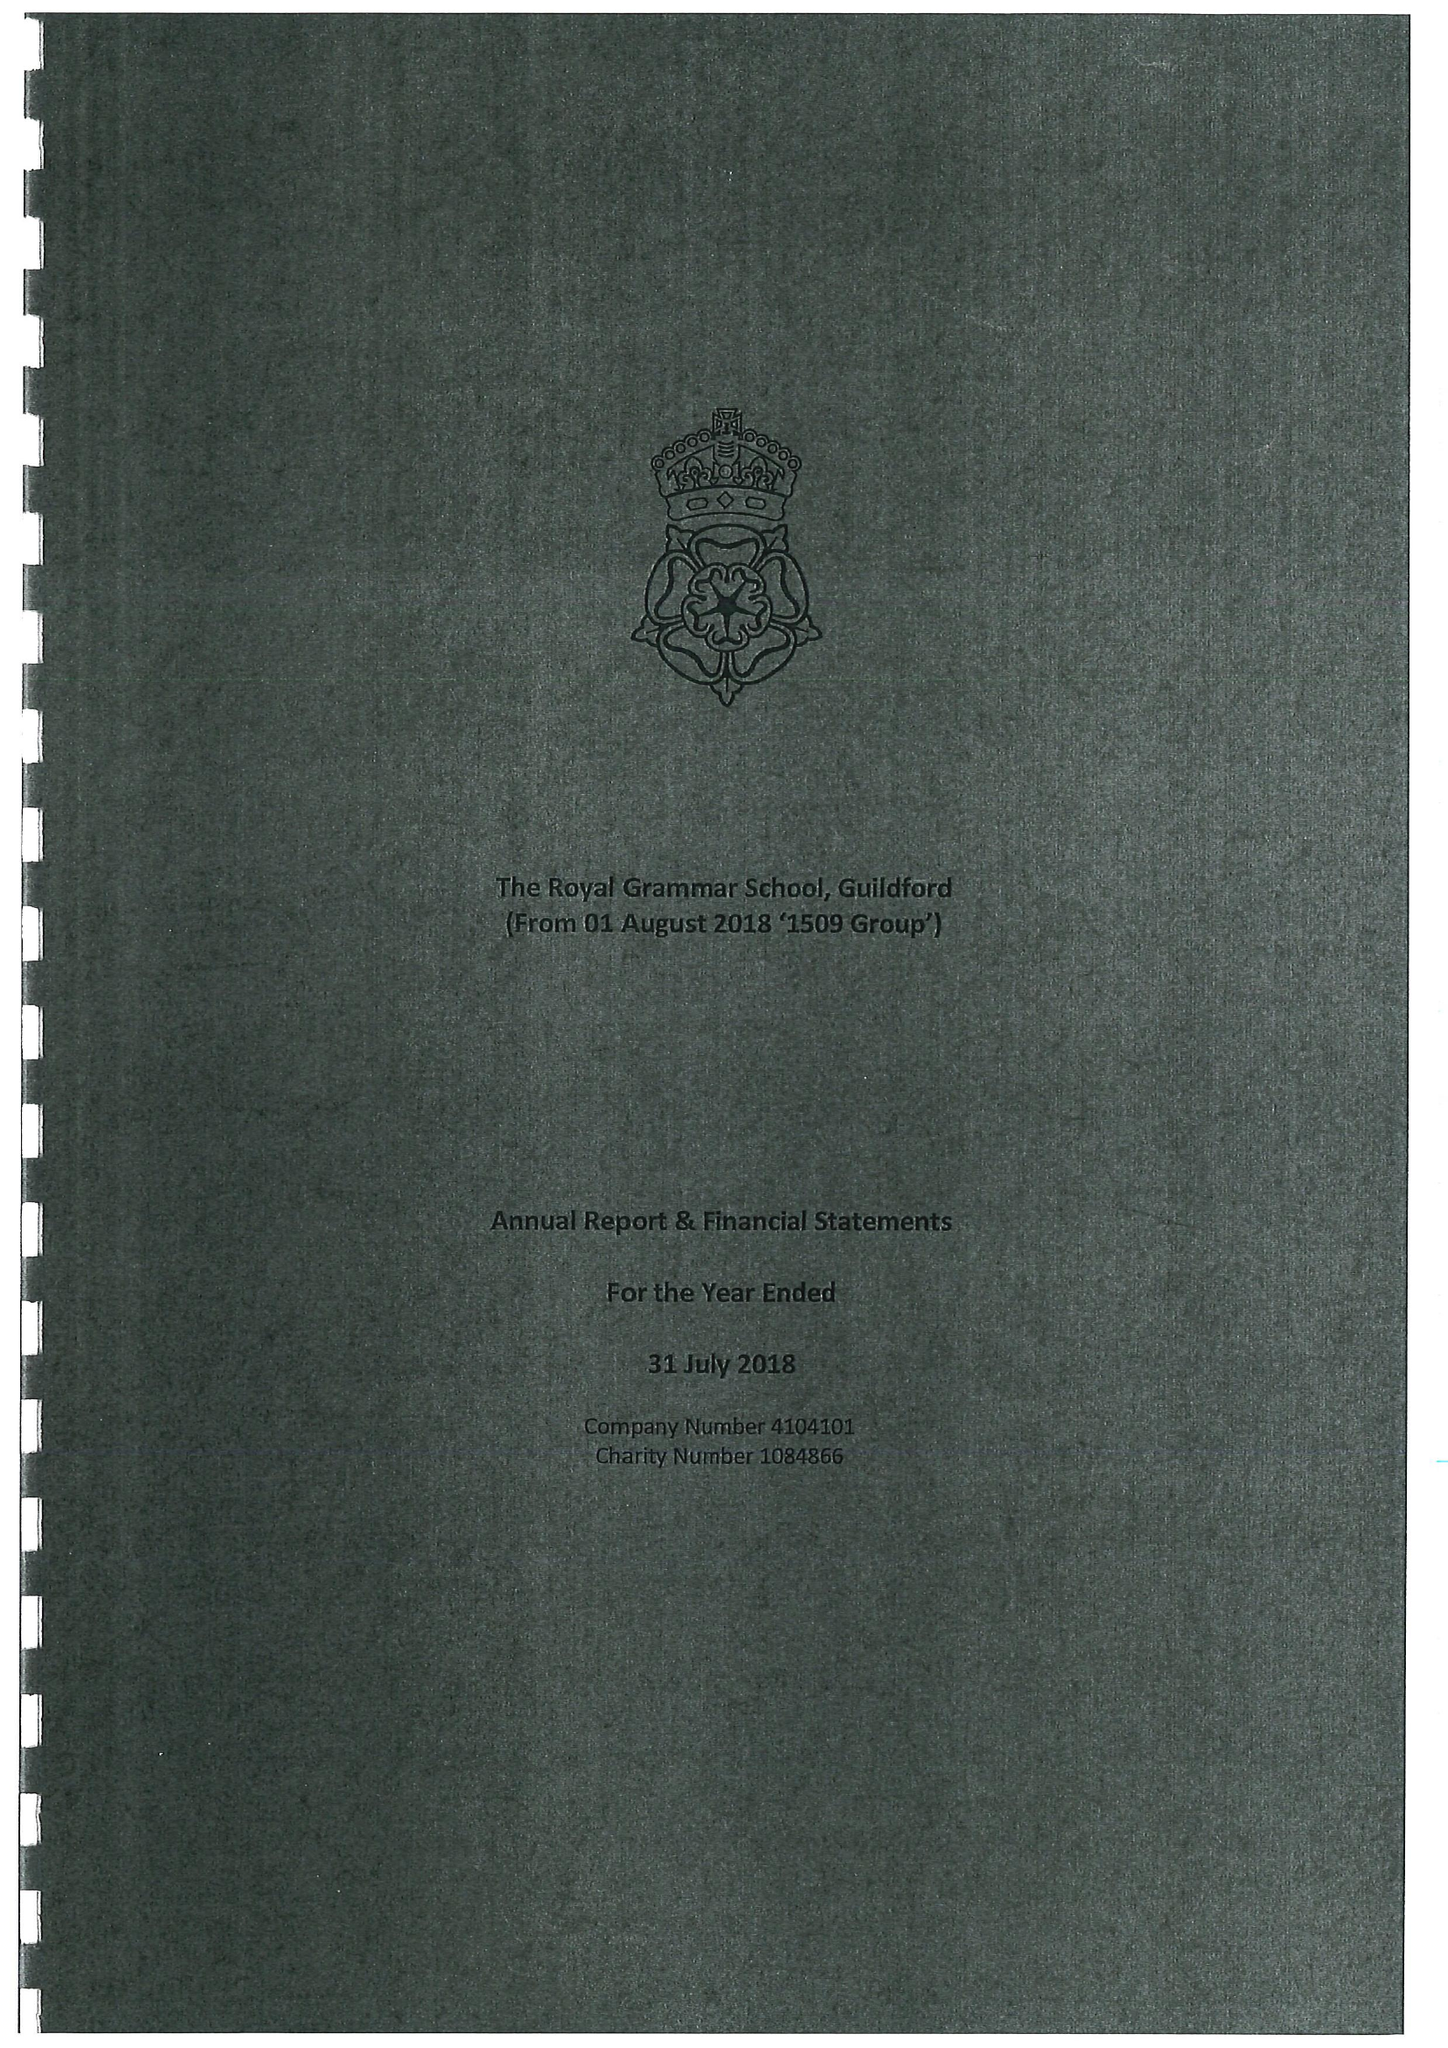What is the value for the address__street_line?
Answer the question using a single word or phrase. HIGH STREET 